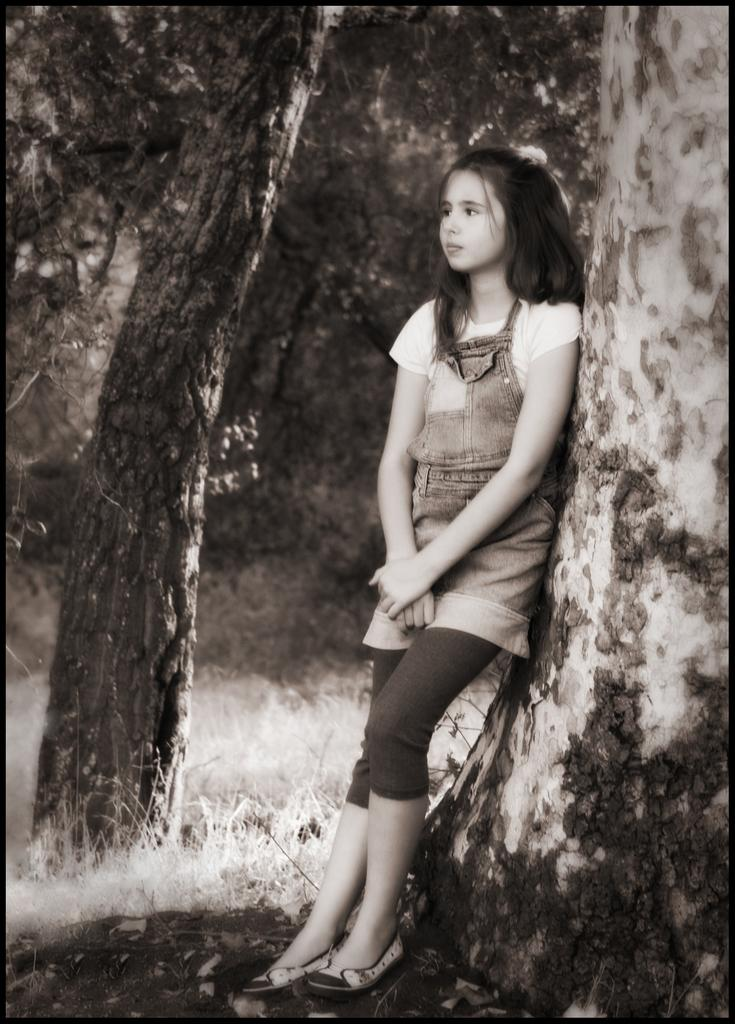Who is the main subject in the image? There is a girl in the image. What is the girl doing in the image? The girl is standing on the ground. What type of vegetation is present in the image? Grass is present in the image. What can be seen in the background of the image? There are trees in the background of the image. What type of robin is perched on the girl's foot in the image? There is no robin present in the image, and the girl's foot is not mentioned in the facts provided. 